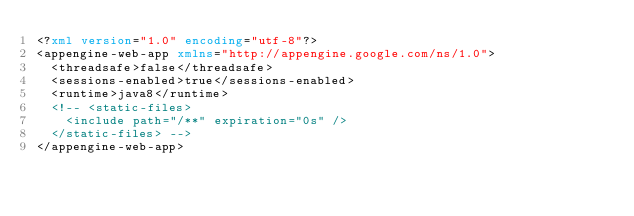Convert code to text. <code><loc_0><loc_0><loc_500><loc_500><_XML_><?xml version="1.0" encoding="utf-8"?>
<appengine-web-app xmlns="http://appengine.google.com/ns/1.0">
  <threadsafe>false</threadsafe>
  <sessions-enabled>true</sessions-enabled>
  <runtime>java8</runtime>
  <!-- <static-files>
    <include path="/**" expiration="0s" />
  </static-files> -->
</appengine-web-app></code> 